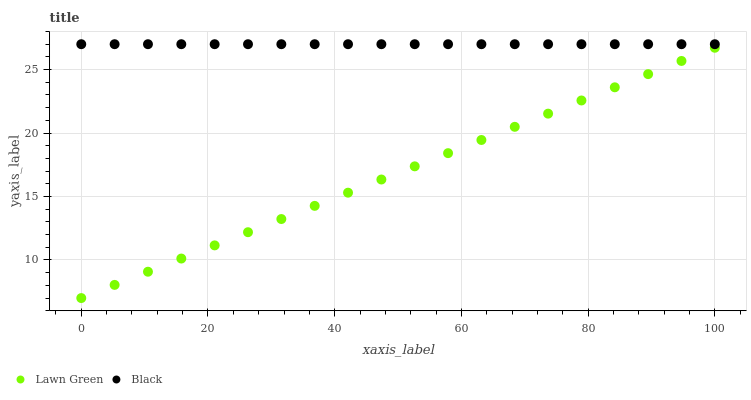Does Lawn Green have the minimum area under the curve?
Answer yes or no. Yes. Does Black have the maximum area under the curve?
Answer yes or no. Yes. Does Black have the minimum area under the curve?
Answer yes or no. No. Is Black the smoothest?
Answer yes or no. Yes. Is Lawn Green the roughest?
Answer yes or no. Yes. Is Black the roughest?
Answer yes or no. No. Does Lawn Green have the lowest value?
Answer yes or no. Yes. Does Black have the lowest value?
Answer yes or no. No. Does Black have the highest value?
Answer yes or no. Yes. Is Lawn Green less than Black?
Answer yes or no. Yes. Is Black greater than Lawn Green?
Answer yes or no. Yes. Does Lawn Green intersect Black?
Answer yes or no. No. 